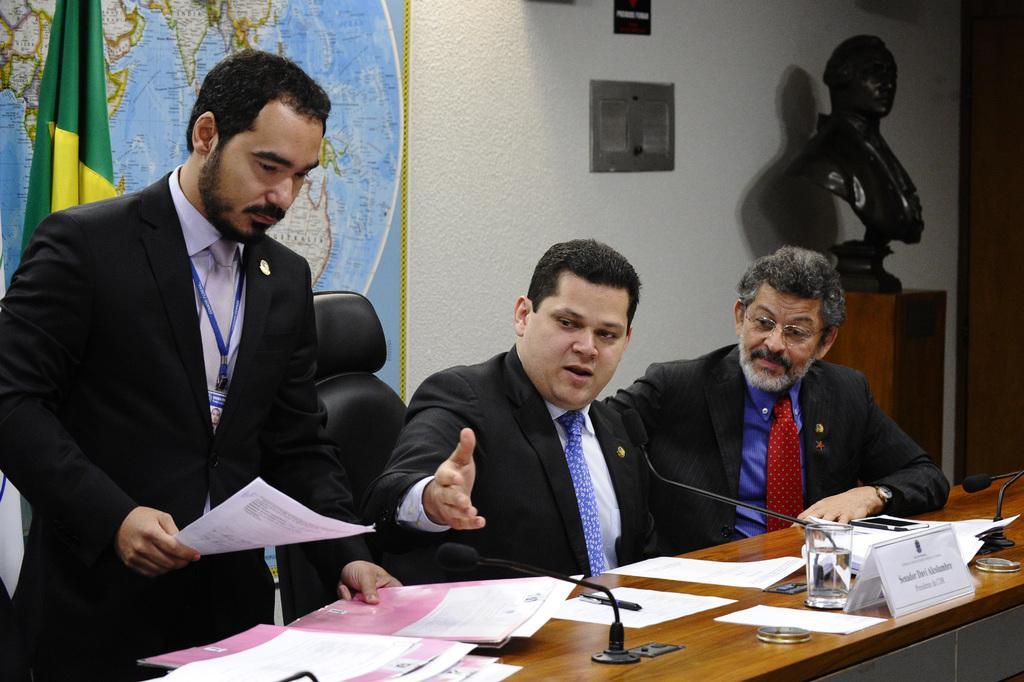How would you summarize this image in a sentence or two? In this image there is a person standing and holding papers in his hand, beside him there are two people sitting in chairs, in front of them on the table there are mics, glass of water, papers and name boards. Behind them there is a flag, behind the flag there is a map, some objects and photo frames on the wall. In front of the pole there is a statue on a wooden stool. 